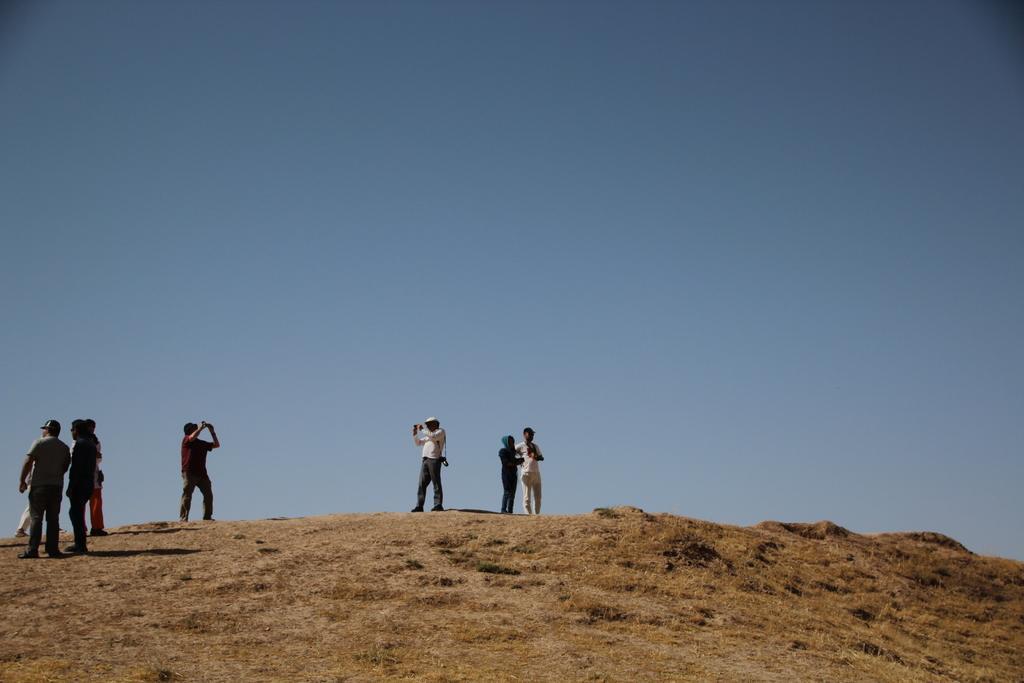Could you give a brief overview of what you see in this image? Here we can see few persons on the ground. In the background there is sky. 